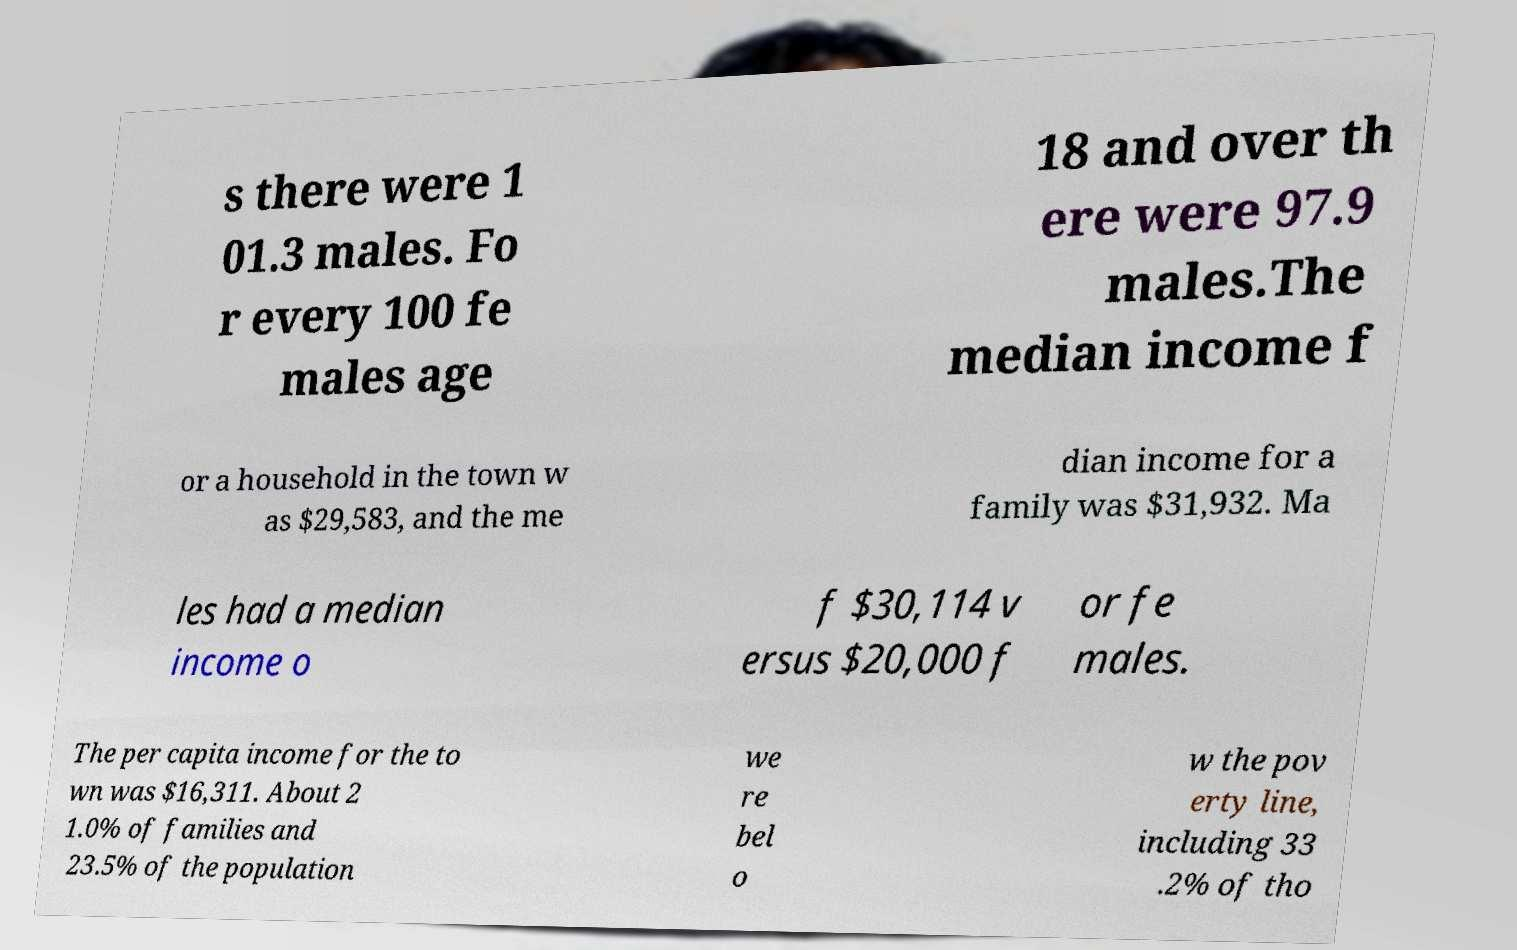Can you accurately transcribe the text from the provided image for me? s there were 1 01.3 males. Fo r every 100 fe males age 18 and over th ere were 97.9 males.The median income f or a household in the town w as $29,583, and the me dian income for a family was $31,932. Ma les had a median income o f $30,114 v ersus $20,000 f or fe males. The per capita income for the to wn was $16,311. About 2 1.0% of families and 23.5% of the population we re bel o w the pov erty line, including 33 .2% of tho 